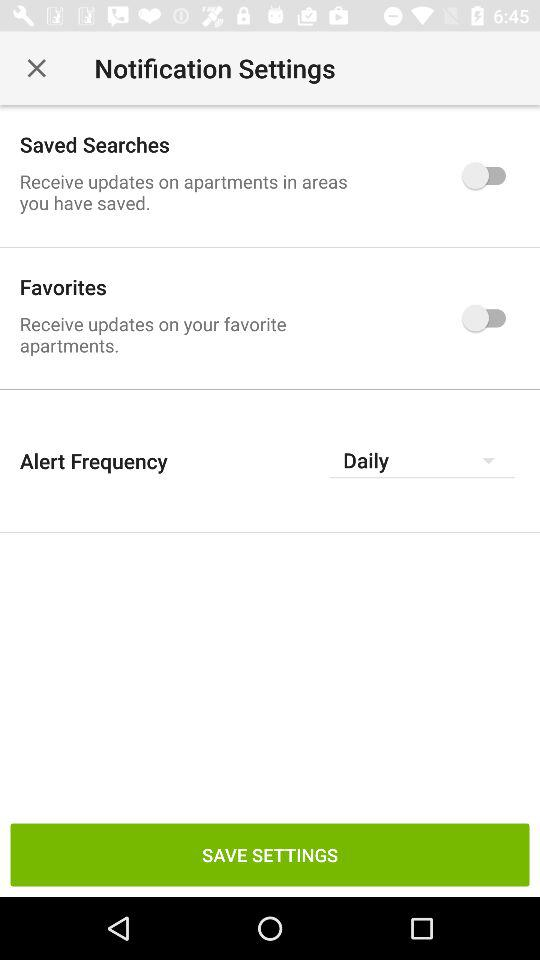How many more saved searches notifications are enabled than favorite apartment notifications?
Answer the question using a single word or phrase. 1 